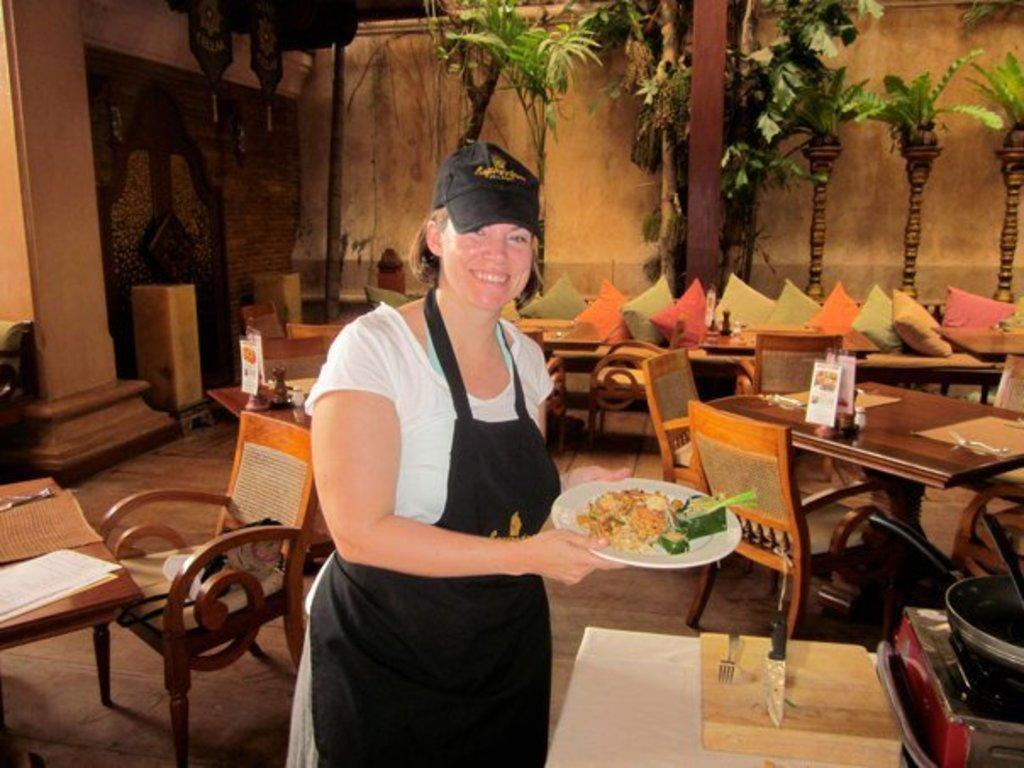Who is present in the image? There is a woman in the image. What is the woman holding in the image? The woman is holding a plate of food. What type of furniture can be seen in the background of the image? There are sofas, chairs, and tables in the background of the image. What is the setting of the image? The image appears to be set in a room, as there is a wall in the background. What utensils are visible in the image? There is a knife and fork on the right side of the image. What type of boat can be seen in the image? There is no boat present in the image. What angle is the tank positioned at in the image? There is no tank present in the image. 